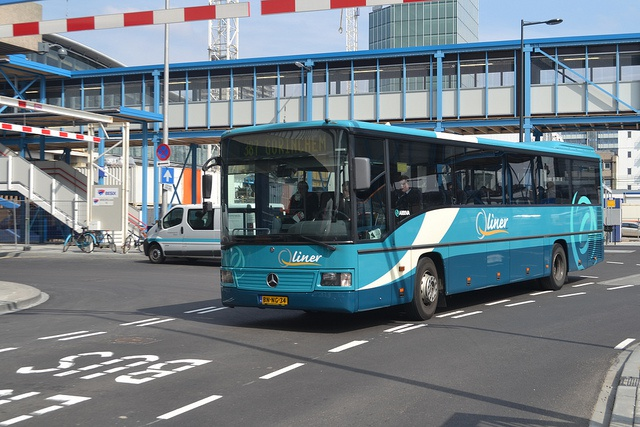Describe the objects in this image and their specific colors. I can see bus in gray, black, blue, and lightblue tones, car in gray, black, darkgray, and lightgray tones, truck in gray, black, darkgray, and lightgray tones, people in gray, black, purple, and maroon tones, and bicycle in gray, darkgray, black, and blue tones in this image. 